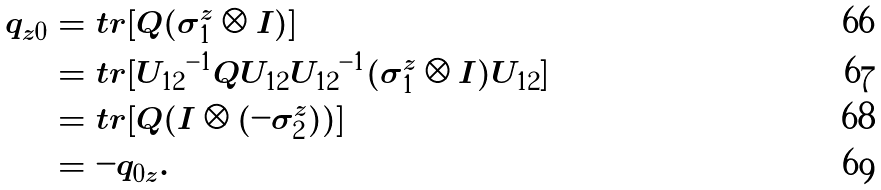<formula> <loc_0><loc_0><loc_500><loc_500>q _ { z 0 } & = t r [ Q ( \sigma _ { 1 } ^ { z } \otimes I ) ] \\ & = t r [ { U _ { 1 2 } } ^ { - 1 } Q U _ { 1 2 } { U _ { 1 2 } } ^ { - 1 } ( \sigma _ { 1 } ^ { z } \otimes I ) U _ { 1 2 } ] \\ & = t r [ Q ( I \otimes ( - \sigma _ { 2 } ^ { z } ) ) ] \\ & = - q _ { 0 z } .</formula> 